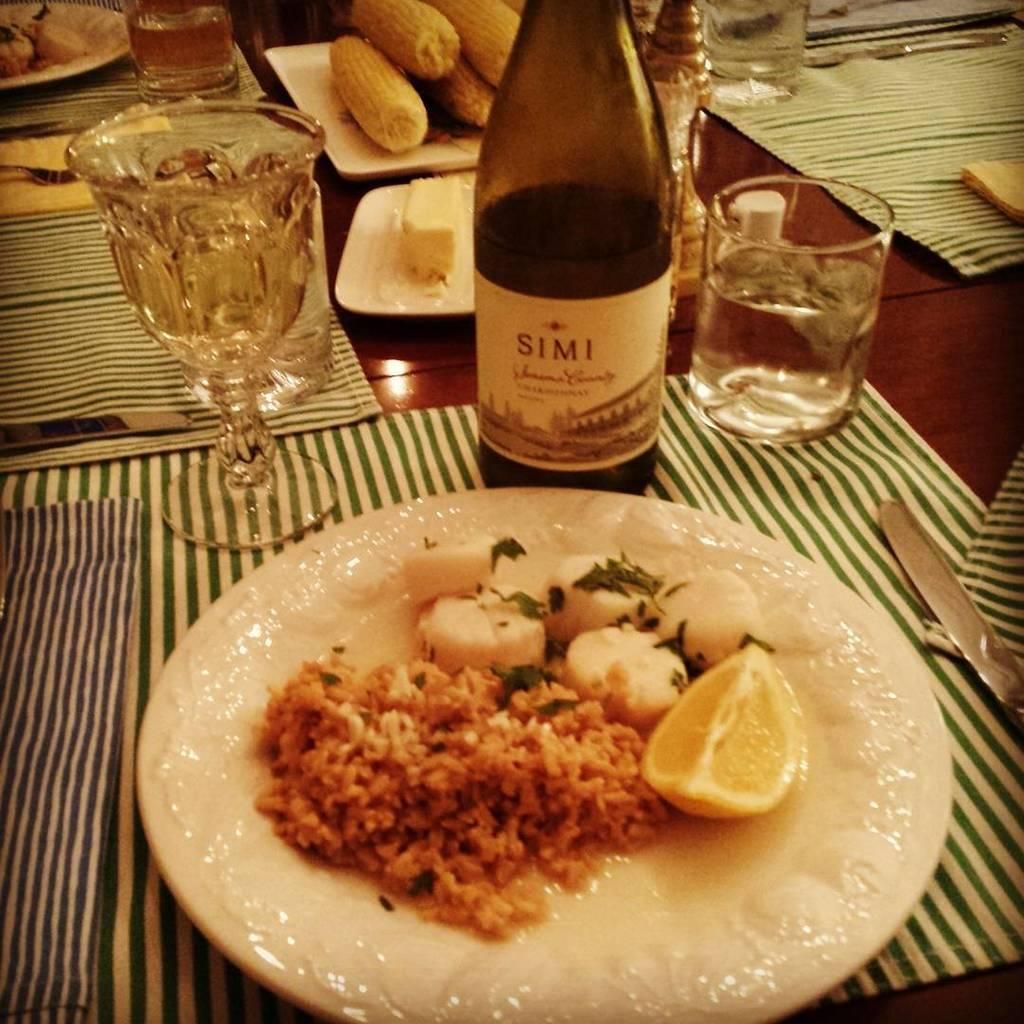<image>
Provide a brief description of the given image. the name Simi is on a wine bottle 